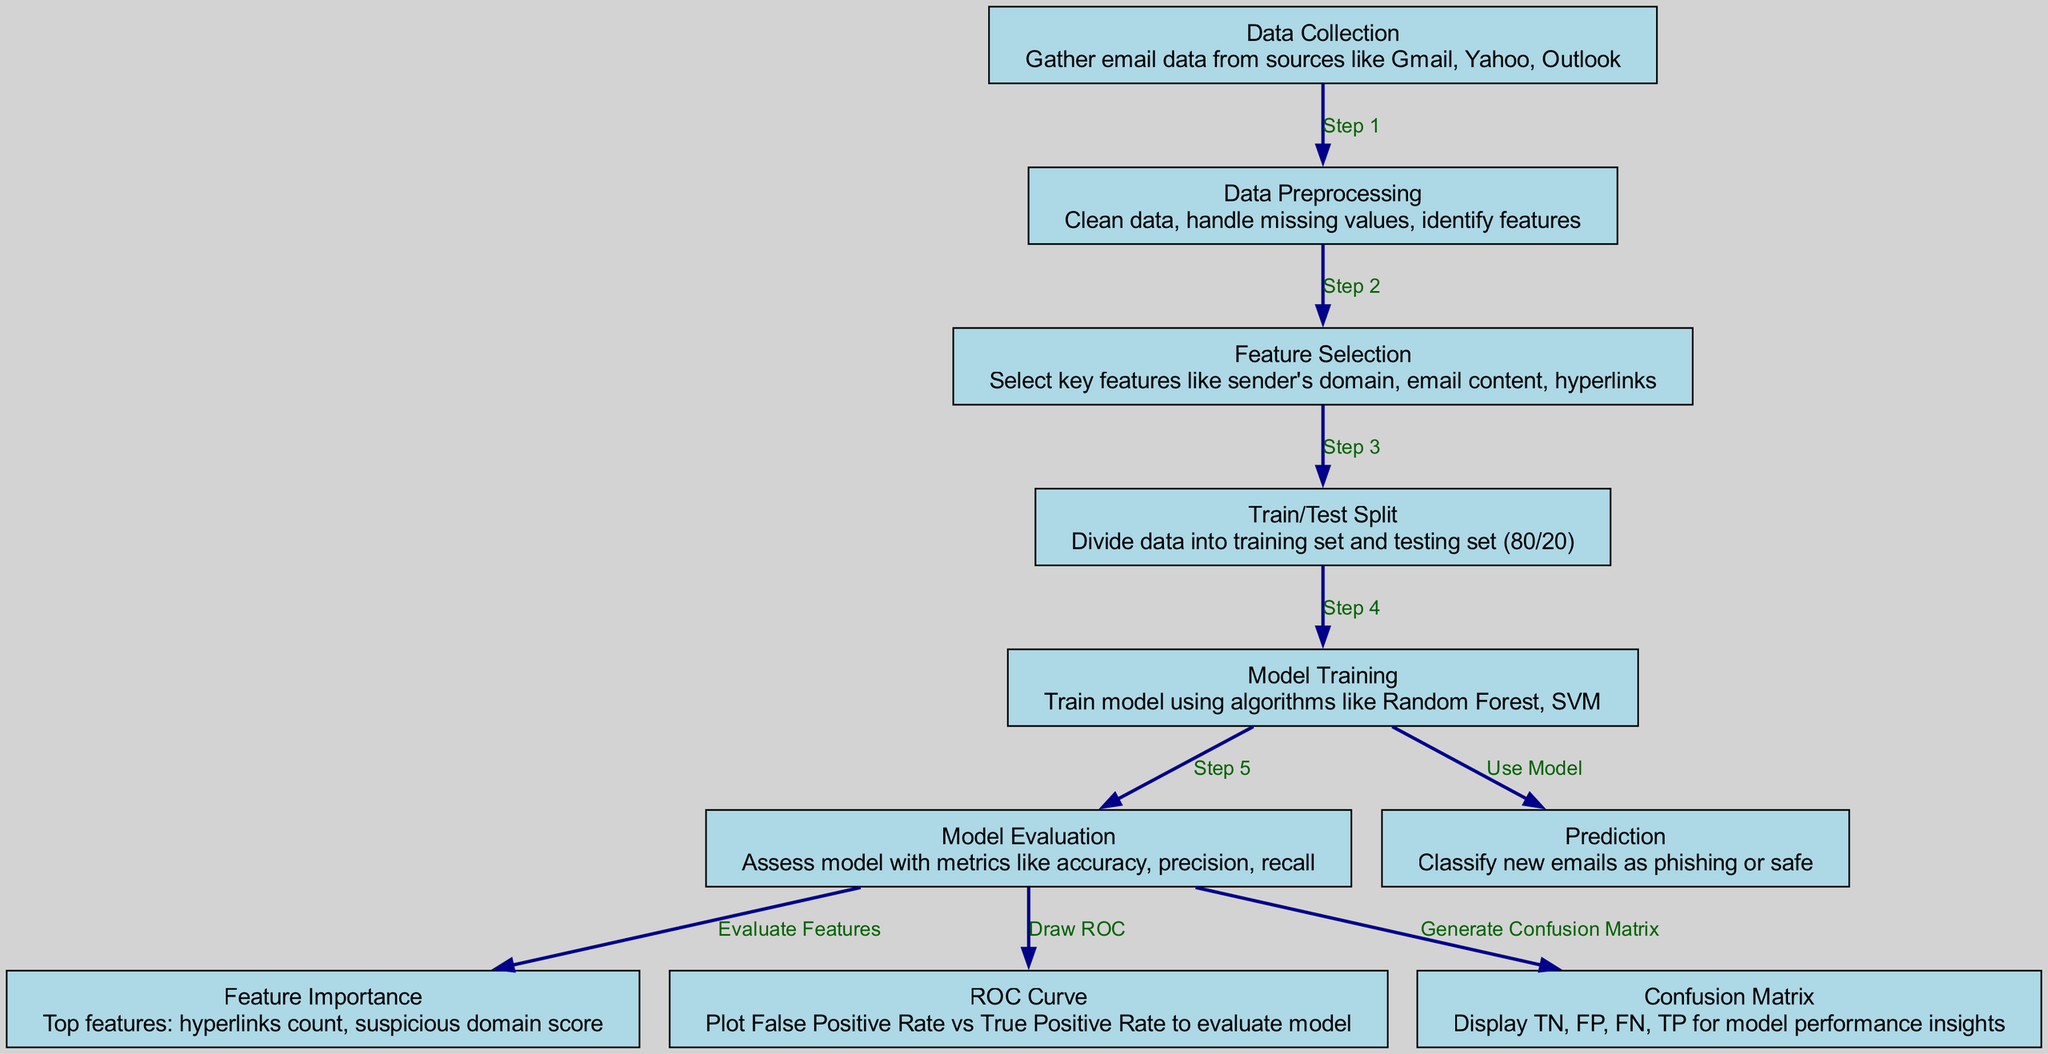What is the first step in the model overview? The first step according to the diagram is "Data Collection," which involves gathering email data from various sources.
Answer: Data Collection How many nodes are present in the diagram? By counting the nodes depicted in the diagram, we see there are a total of 10 nodes representing different steps or components in the machine learning process.
Answer: 10 Which node follows "Feature Selection"? "Train/Test Split" is the node that follows "Feature Selection" in the sequence of steps depicted in the diagram, indicating the division of data for training and testing.
Answer: Train/Test Split What are two algorithms used in the "Model Training" step? The diagram specifies the algorithms used during the "Model Training" step as Random Forest and SVM, indicating the machine learning methods applied to train the model.
Answer: Random Forest, SVM What does the "ROC Curve" represent in the model evaluation process? The "ROC Curve" in the diagram represents the plot of False Positive Rate versus True Positive Rate, which is essential for evaluating the performance of the machine learning model.
Answer: False Positive Rate vs True Positive Rate Why is the "Confusion Matrix" important? The "Confusion Matrix" provides insights into model performance by displaying True Negatives, False Positives, False Negatives, and True Positives, allowing a detailed understanding of classification accuracy.
Answer: Display TN, FP, FN, TP Which two features are considered most important based on the diagram? According to the "Feature Importance" node, the two key features identified are hyperlinks count and suspicious domain score, highlighting aspects that significantly influence phishing detection.
Answer: Hyperlinks count, suspicious domain score What percentage of data is used for training in the "Train/Test Split"? The "Train/Test Split" node indicates that 80% of the data is set aside for training purposes, establishing a standard ratio for machine learning model evaluation.
Answer: 80 percent Which step comes directly before "Prediction"? The step that comes directly before "Prediction" is "Model Training," which is crucial as it prepares the model to classify new emails effectively as phishing or safe.
Answer: Model Training What is the final outcome of the model as shown in the diagram? The final outcome indicated in the diagram is the classification of new emails as either phishing or safe, which is the primary objective of the machine learning model.
Answer: Classify new emails as phishing or safe 